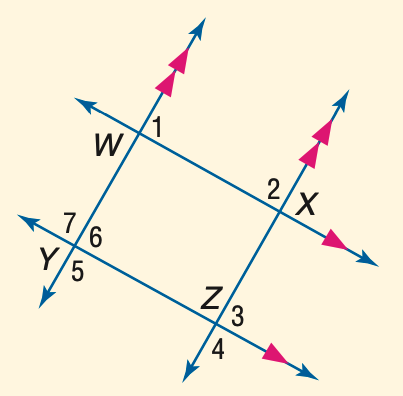Answer the mathemtical geometry problem and directly provide the correct option letter.
Question: In the figure, m \angle 1 = 53. Find the measure of \angle 4.
Choices: A: 113 B: 117 C: 123 D: 127 D 